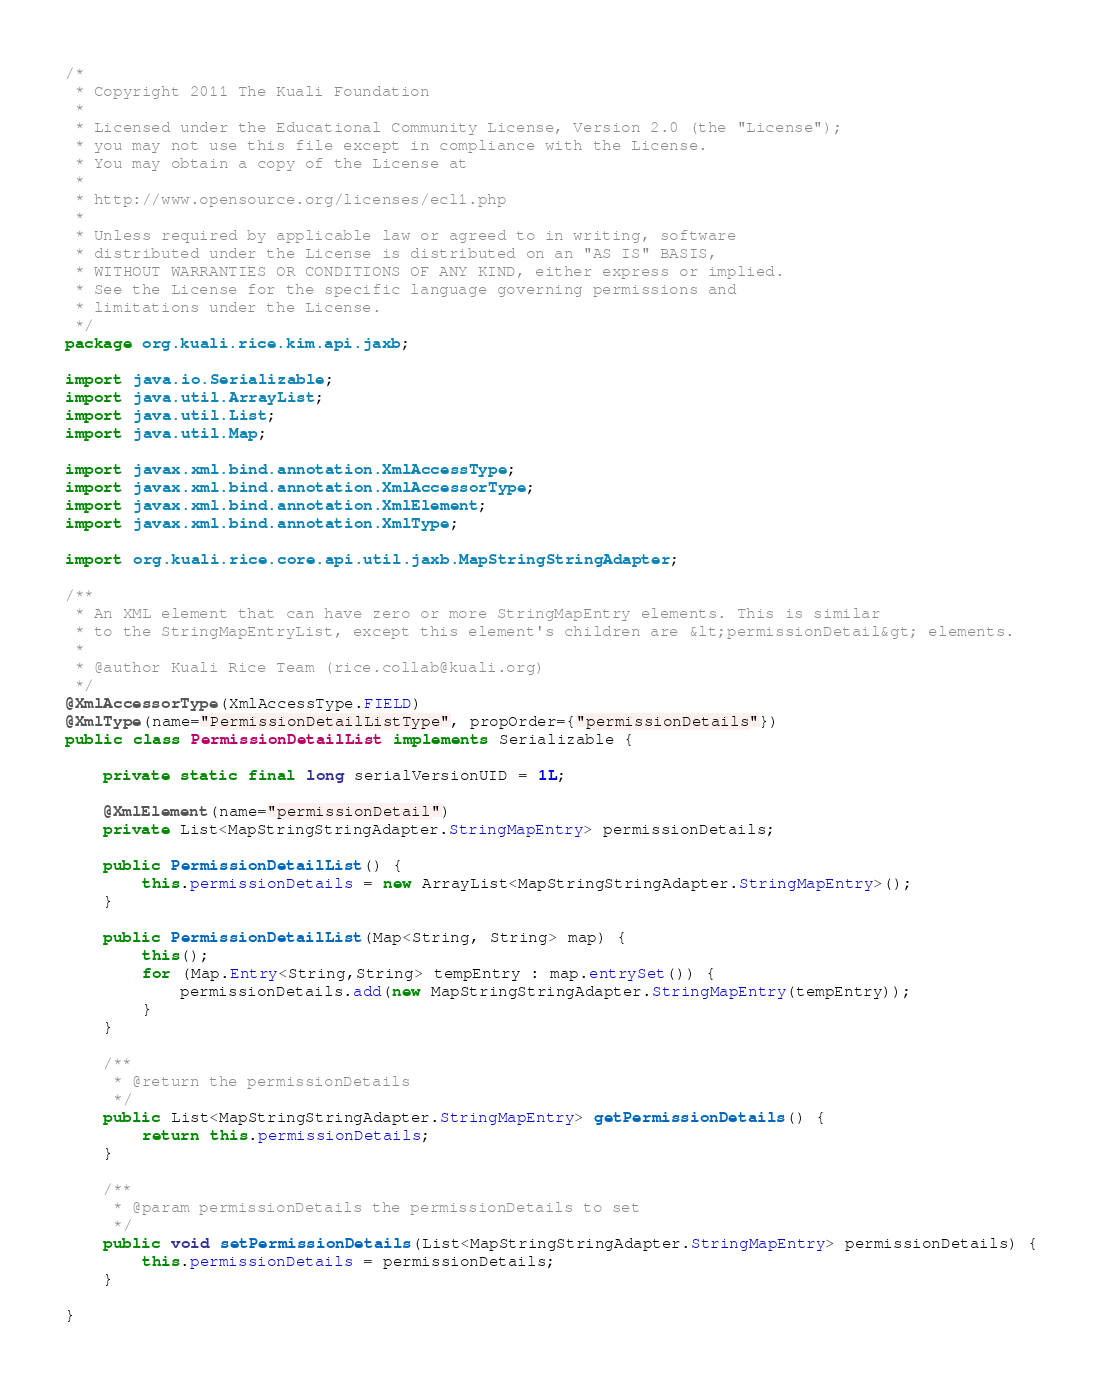<code> <loc_0><loc_0><loc_500><loc_500><_Java_>/*
 * Copyright 2011 The Kuali Foundation
 *
 * Licensed under the Educational Community License, Version 2.0 (the "License");
 * you may not use this file except in compliance with the License.
 * You may obtain a copy of the License at
 *
 * http://www.opensource.org/licenses/ecl1.php
 *
 * Unless required by applicable law or agreed to in writing, software
 * distributed under the License is distributed on an "AS IS" BASIS,
 * WITHOUT WARRANTIES OR CONDITIONS OF ANY KIND, either express or implied.
 * See the License for the specific language governing permissions and
 * limitations under the License.
 */
package org.kuali.rice.kim.api.jaxb;

import java.io.Serializable;
import java.util.ArrayList;
import java.util.List;
import java.util.Map;

import javax.xml.bind.annotation.XmlAccessType;
import javax.xml.bind.annotation.XmlAccessorType;
import javax.xml.bind.annotation.XmlElement;
import javax.xml.bind.annotation.XmlType;

import org.kuali.rice.core.api.util.jaxb.MapStringStringAdapter;

/**
 * An XML element that can have zero or more StringMapEntry elements. This is similar
 * to the StringMapEntryList, except this element's children are &lt;permissionDetail&gt; elements.
 * 
 * @author Kuali Rice Team (rice.collab@kuali.org)
 */
@XmlAccessorType(XmlAccessType.FIELD)
@XmlType(name="PermissionDetailListType", propOrder={"permissionDetails"})
public class PermissionDetailList implements Serializable {

    private static final long serialVersionUID = 1L;
    
    @XmlElement(name="permissionDetail")
    private List<MapStringStringAdapter.StringMapEntry> permissionDetails;
    
    public PermissionDetailList() {
        this.permissionDetails = new ArrayList<MapStringStringAdapter.StringMapEntry>();
    }
    
    public PermissionDetailList(Map<String, String> map) {
        this();
        for (Map.Entry<String,String> tempEntry : map.entrySet()) {
            permissionDetails.add(new MapStringStringAdapter.StringMapEntry(tempEntry));
        }
    }

    /**
     * @return the permissionDetails
     */
    public List<MapStringStringAdapter.StringMapEntry> getPermissionDetails() {
        return this.permissionDetails;
    }

    /**
     * @param permissionDetails the permissionDetails to set
     */
    public void setPermissionDetails(List<MapStringStringAdapter.StringMapEntry> permissionDetails) {
        this.permissionDetails = permissionDetails;
    }
    
}
</code> 